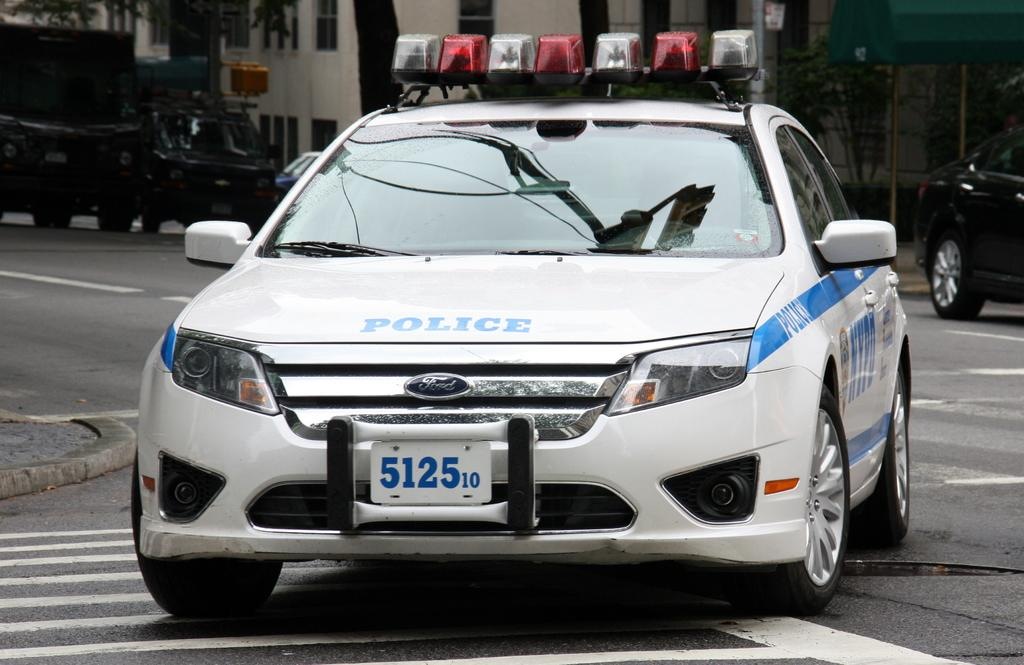What types of objects can be seen in the image? There are vehicles, trees, poles, buildings, and an object in the top right corner of the image. Can you describe the vehicles in the image? The vehicles in the image are not specified, but they are present. What type of natural elements are visible in the image? Trees are the natural elements visible in the image. What type of man-made structures can be seen in the image? Buildings are the man-made structures visible in the image. What is visible on the ground in the image? The ground is visible in the image, but no specific details are provided. What type of stew is being served in the image? There is no stew present in the image; it features vehicles, trees, poles, buildings, and an object in the top right corner. Is there an airport visible in the image? There is no mention of an airport in the provided facts, and therefore it cannot be confirmed or denied. 